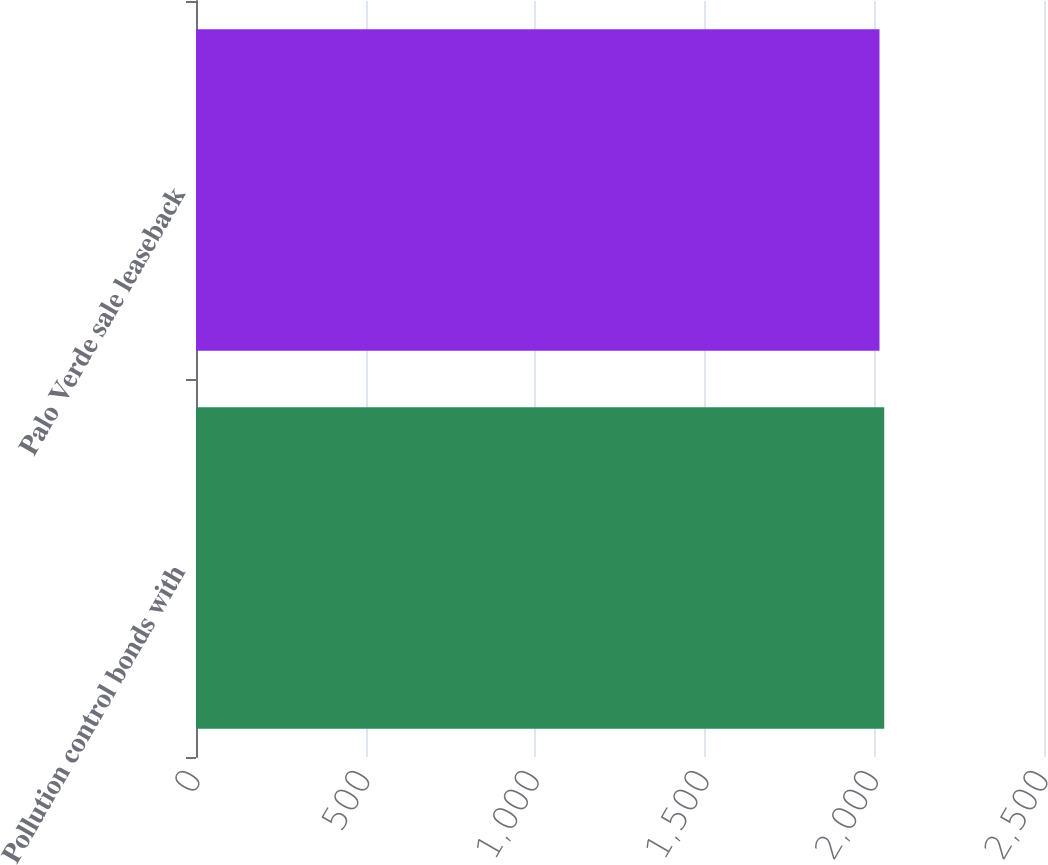Convert chart to OTSL. <chart><loc_0><loc_0><loc_500><loc_500><bar_chart><fcel>Pollution control bonds with<fcel>Palo Verde sale leaseback<nl><fcel>2029<fcel>2015<nl></chart> 